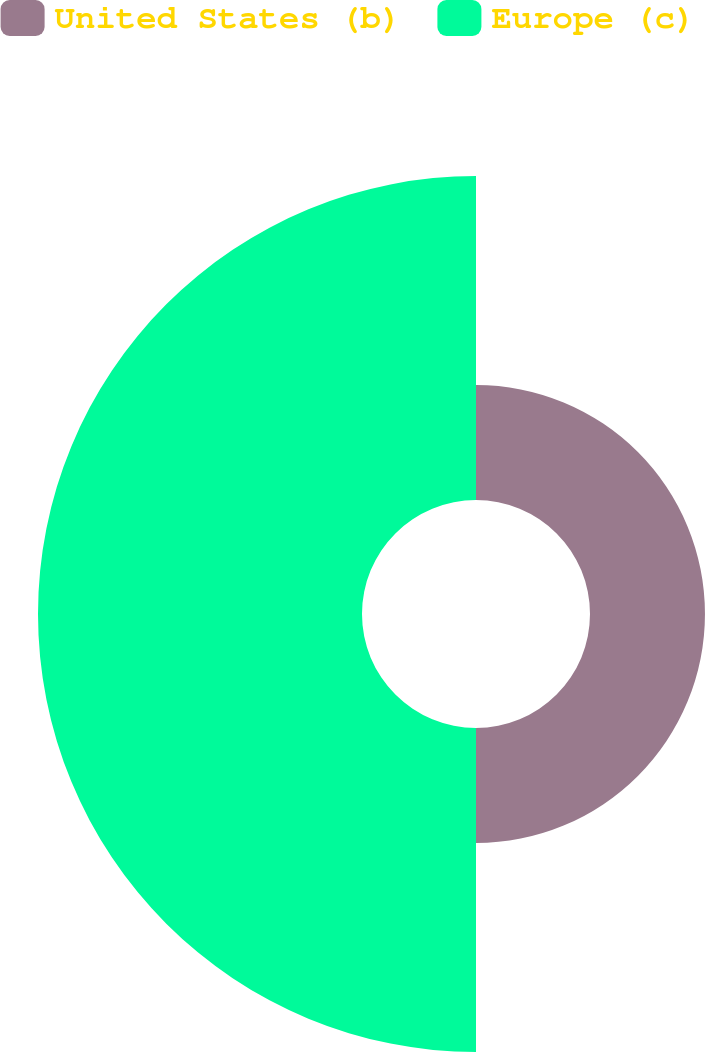<chart> <loc_0><loc_0><loc_500><loc_500><pie_chart><fcel>United States (b)<fcel>Europe (c)<nl><fcel>26.19%<fcel>73.81%<nl></chart> 